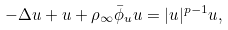<formula> <loc_0><loc_0><loc_500><loc_500>- \Delta u + u + \rho _ { \infty } \bar { \phi } _ { u } u = | u | ^ { p - 1 } u ,</formula> 